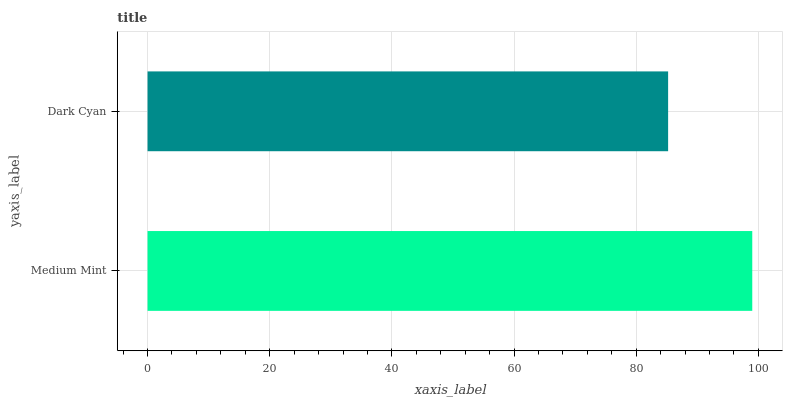Is Dark Cyan the minimum?
Answer yes or no. Yes. Is Medium Mint the maximum?
Answer yes or no. Yes. Is Dark Cyan the maximum?
Answer yes or no. No. Is Medium Mint greater than Dark Cyan?
Answer yes or no. Yes. Is Dark Cyan less than Medium Mint?
Answer yes or no. Yes. Is Dark Cyan greater than Medium Mint?
Answer yes or no. No. Is Medium Mint less than Dark Cyan?
Answer yes or no. No. Is Medium Mint the high median?
Answer yes or no. Yes. Is Dark Cyan the low median?
Answer yes or no. Yes. Is Dark Cyan the high median?
Answer yes or no. No. Is Medium Mint the low median?
Answer yes or no. No. 